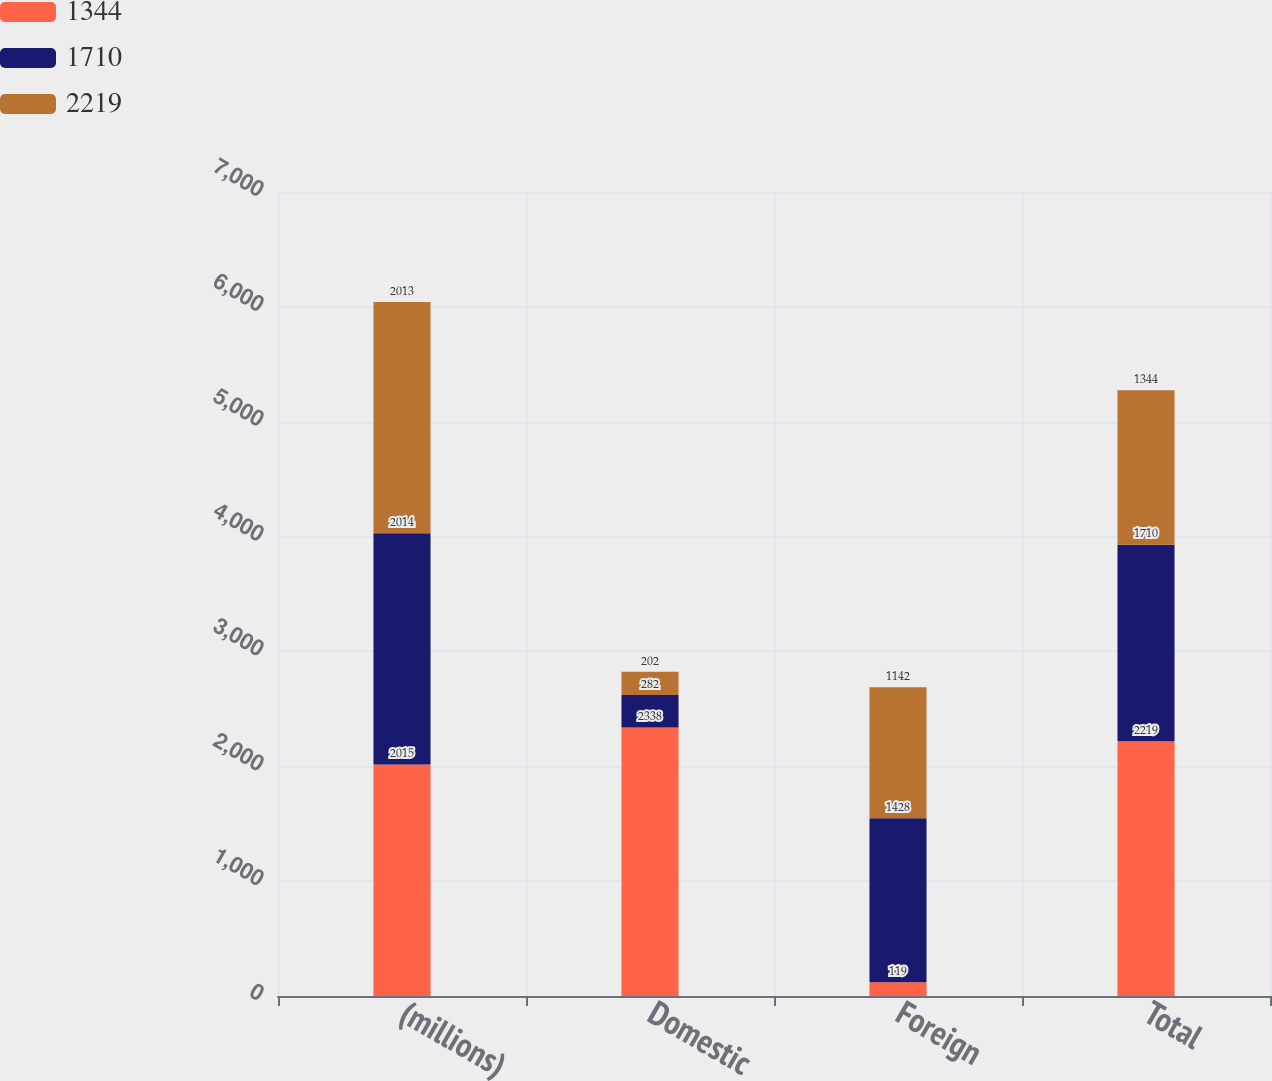Convert chart to OTSL. <chart><loc_0><loc_0><loc_500><loc_500><stacked_bar_chart><ecel><fcel>(millions)<fcel>Domestic<fcel>Foreign<fcel>Total<nl><fcel>1344<fcel>2015<fcel>2338<fcel>119<fcel>2219<nl><fcel>1710<fcel>2014<fcel>282<fcel>1428<fcel>1710<nl><fcel>2219<fcel>2013<fcel>202<fcel>1142<fcel>1344<nl></chart> 